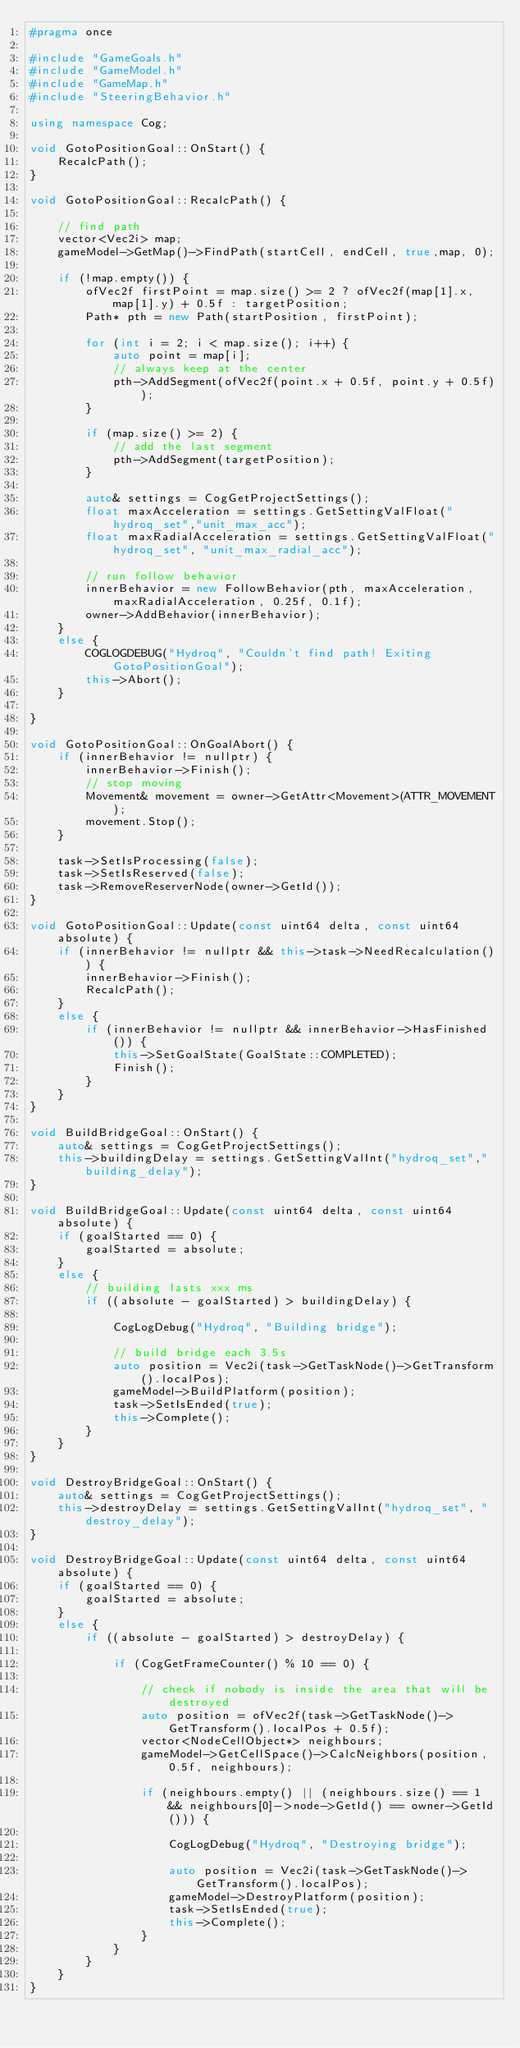<code> <loc_0><loc_0><loc_500><loc_500><_C++_>#pragma once

#include "GameGoals.h"
#include "GameModel.h"
#include "GameMap.h"
#include "SteeringBehavior.h"

using namespace Cog;

void GotoPositionGoal::OnStart() {
	RecalcPath();
}

void GotoPositionGoal::RecalcPath() {

	// find path
	vector<Vec2i> map;
	gameModel->GetMap()->FindPath(startCell, endCell, true,map, 0);

	if (!map.empty()) {
		ofVec2f firstPoint = map.size() >= 2 ? ofVec2f(map[1].x, map[1].y) + 0.5f : targetPosition;
		Path* pth = new Path(startPosition, firstPoint);

		for (int i = 2; i < map.size(); i++) {
			auto point = map[i];
			// always keep at the center
			pth->AddSegment(ofVec2f(point.x + 0.5f, point.y + 0.5f));
		}

		if (map.size() >= 2) {
			// add the last segment
			pth->AddSegment(targetPosition);
		}
		
		auto& settings = CogGetProjectSettings();
		float maxAcceleration = settings.GetSettingValFloat("hydroq_set","unit_max_acc");
		float maxRadialAcceleration = settings.GetSettingValFloat("hydroq_set", "unit_max_radial_acc");

		// run follow behavior
		innerBehavior = new FollowBehavior(pth, maxAcceleration, maxRadialAcceleration, 0.25f, 0.1f);
		owner->AddBehavior(innerBehavior);
	}
	else {
		COGLOGDEBUG("Hydroq", "Couldn't find path! Exiting GotoPositionGoal");
		this->Abort();
	}

}

void GotoPositionGoal::OnGoalAbort() {
	if (innerBehavior != nullptr) {
		innerBehavior->Finish();
		// stop moving
		Movement& movement = owner->GetAttr<Movement>(ATTR_MOVEMENT);
		movement.Stop();
	}

	task->SetIsProcessing(false);
	task->SetIsReserved(false);
	task->RemoveReserverNode(owner->GetId());
}

void GotoPositionGoal::Update(const uint64 delta, const uint64 absolute) {
	if (innerBehavior != nullptr && this->task->NeedRecalculation()) {
		innerBehavior->Finish();
		RecalcPath();
	}
	else {
		if (innerBehavior != nullptr && innerBehavior->HasFinished()) {
			this->SetGoalState(GoalState::COMPLETED);
			Finish();
		}
	}
}

void BuildBridgeGoal::OnStart() {
	auto& settings = CogGetProjectSettings();
	this->buildingDelay = settings.GetSettingValInt("hydroq_set","building_delay");
}

void BuildBridgeGoal::Update(const uint64 delta, const uint64 absolute) {
	if (goalStarted == 0) {
		goalStarted = absolute;
	}
	else {
		// building lasts xxx ms
		if ((absolute - goalStarted) > buildingDelay) {

			CogLogDebug("Hydroq", "Building bridge");
			
			// build bridge each 3.5s
			auto position = Vec2i(task->GetTaskNode()->GetTransform().localPos);
			gameModel->BuildPlatform(position);
			task->SetIsEnded(true);
			this->Complete();
		}
	}
}

void DestroyBridgeGoal::OnStart() {
	auto& settings = CogGetProjectSettings();
	this->destroyDelay = settings.GetSettingValInt("hydroq_set", "destroy_delay");
}

void DestroyBridgeGoal::Update(const uint64 delta, const uint64 absolute) {
	if (goalStarted == 0) {
		goalStarted = absolute;
	}
	else {
		if ((absolute - goalStarted) > destroyDelay) {
			
			if (CogGetFrameCounter() % 10 == 0) {
				
				// check if nobody is inside the area that will be destroyed
				auto position = ofVec2f(task->GetTaskNode()->GetTransform().localPos + 0.5f);
				vector<NodeCellObject*> neighbours;
				gameModel->GetCellSpace()->CalcNeighbors(position, 0.5f, neighbours);

				if (neighbours.empty() || (neighbours.size() == 1 && neighbours[0]->node->GetId() == owner->GetId())) {

					CogLogDebug("Hydroq", "Destroying bridge");

					auto position = Vec2i(task->GetTaskNode()->GetTransform().localPos);
					gameModel->DestroyPlatform(position);
					task->SetIsEnded(true);
					this->Complete();
				}
			}
		}
	}
}
</code> 